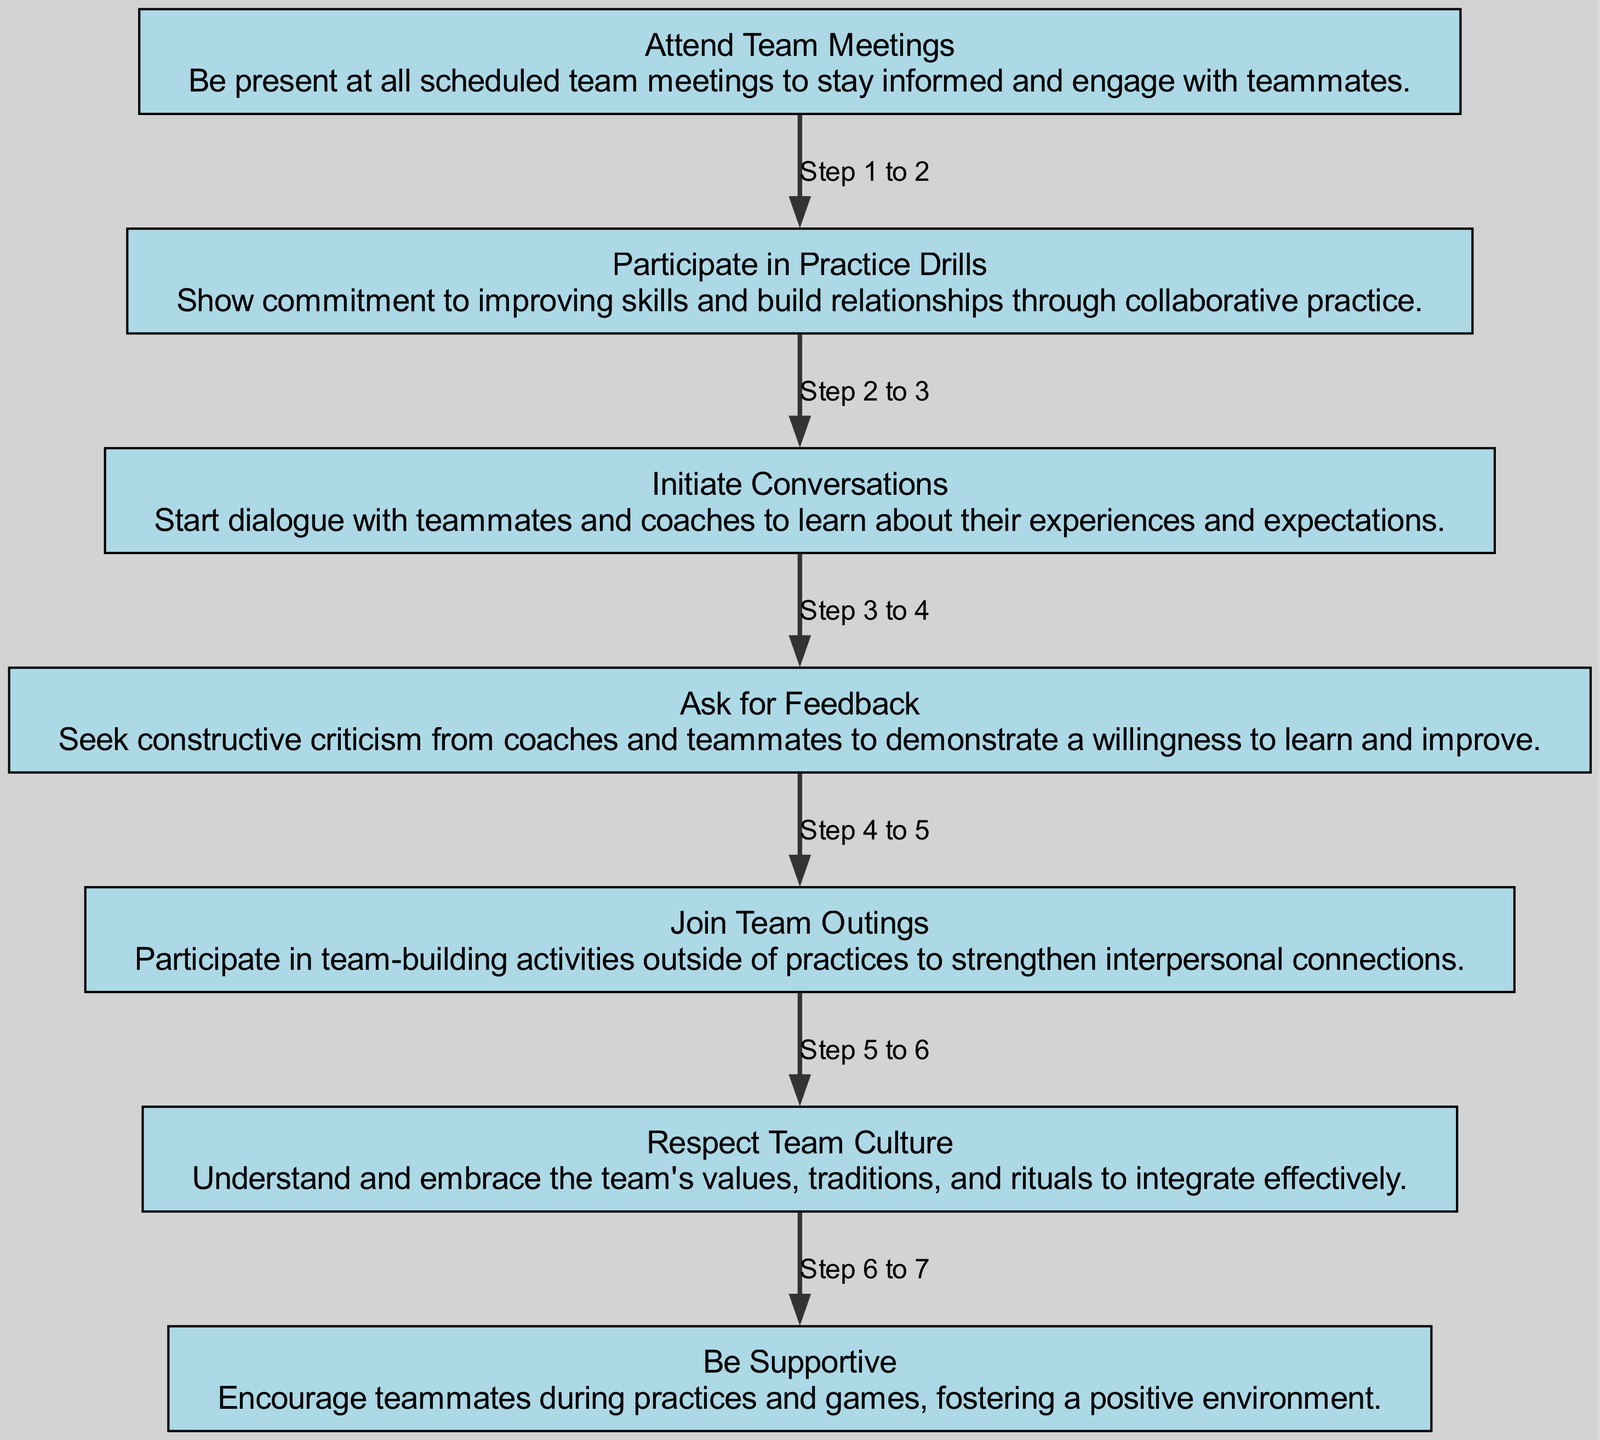What is the first step in building rapport with teammates? The flow chart starts with "Attend Team Meetings," which is outlined as the initial node. This node is where the process begins in building rapport.
Answer: Attend Team Meetings How many total steps are in the diagram? By counting the elements listed in the flow chart, there are 7 steps represented in total, from the first step to the last.
Answer: 7 What comes after "Participate in Practice Drills"? The flow chart indicates that "Initiate Conversations" directly follows "Participate in Practice Drills," showing a sequential relationship in the flow of steps.
Answer: Initiate Conversations Which step emphasizes understanding team values? The node labeled "Respect Team Culture" specifically mentions understanding and embracing the team's values as key to effective integration, making it clear this is the focus step.
Answer: Respect Team Culture What is the last node in the flow chart? The final step in the sequence shown in the flow chart is "Be Supportive," indicating it's the concluding action for building rapport.
Answer: Be Supportive How does one seek improvement through teamwork? The flow chart outlines "Ask for Feedback" as a specific step in seeking constructive criticism to demonstrate a willingness to learn and improve, reflecting a collaborative effort to improve.
Answer: Ask for Feedback What activity can strengthen interpersonal connections outside of practices? The flow chart explicitly shows "Join Team Outings" as the activity aimed at building stronger relationships among team members beyond regular practice sessions.
Answer: Join Team Outings Which step directly encourages teammates? The node "Be Supportive" focuses on encouraging teammates during practices and games, highlighting this step's role in fostering a positive team atmosphere.
Answer: Be Supportive 